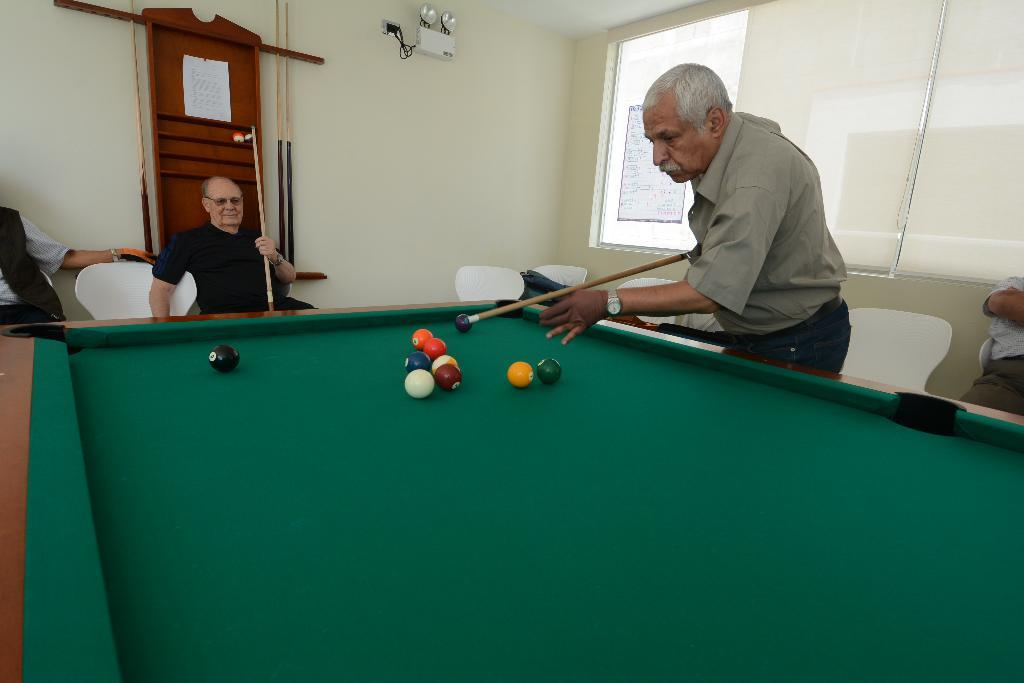How many people are sitting in the chairs in the image? There are two persons sitting on chairs in the image. What activity are they likely engaged in? They are likely playing snooker, as there is a snooker table with balls in the image. What object is one person holding? One person is holding a stick, which is likely a snooker cue. What can be seen in the background of the image? There is a window in the image. What type of fight can be seen taking place in the image? There is no fight taking place in the image; it features two people sitting on chairs and a snooker table. What color is the gold tooth of the person holding the cue? There is no mention of a gold tooth or any teeth in the image; it only shows two people sitting on chairs and a snooker table. 